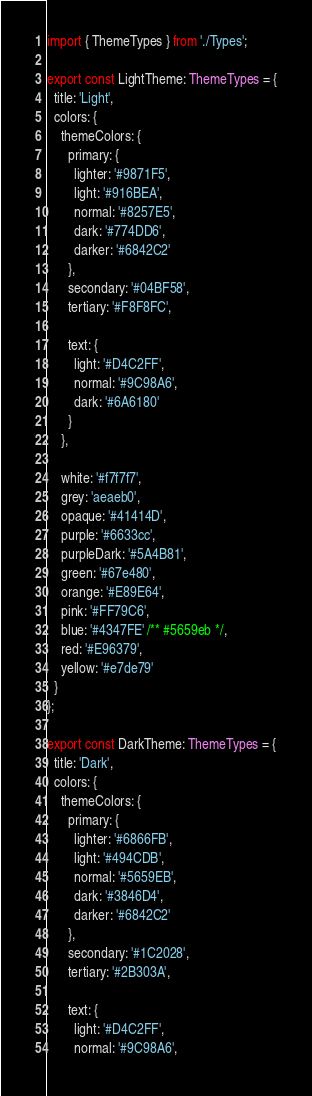<code> <loc_0><loc_0><loc_500><loc_500><_TypeScript_>import { ThemeTypes } from './Types';

export const LightTheme: ThemeTypes = {
  title: 'Light',
  colors: {
    themeColors: {
      primary: {
        lighter: '#9871F5',
        light: '#916BEA',
        normal: '#8257E5',
        dark: '#774DD6',
        darker: '#6842C2'
      },
      secondary: '#04BF58',
      tertiary: '#F8F8FC',

      text: {
        light: '#D4C2FF',
        normal: '#9C98A6',
        dark: '#6A6180'
      }
    },

    white: '#f7f7f7',
    grey: 'aeaeb0',
    opaque: '#41414D',
    purple: '#6633cc',
    purpleDark: '#5A4B81',
    green: '#67e480',
    orange: '#E89E64',
    pink: '#FF79C6',
    blue: '#4347FE' /** #5659eb */,
    red: '#E96379',
    yellow: '#e7de79'
  }
};

export const DarkTheme: ThemeTypes = {
  title: 'Dark',
  colors: {
    themeColors: {
      primary: {
        lighter: '#6866FB',
        light: '#494CDB',
        normal: '#5659EB',
        dark: '#3846D4',
        darker: '#6842C2'
      },
      secondary: '#1C2028',
      tertiary: '#2B303A',

      text: {
        light: '#D4C2FF',
        normal: '#9C98A6',</code> 